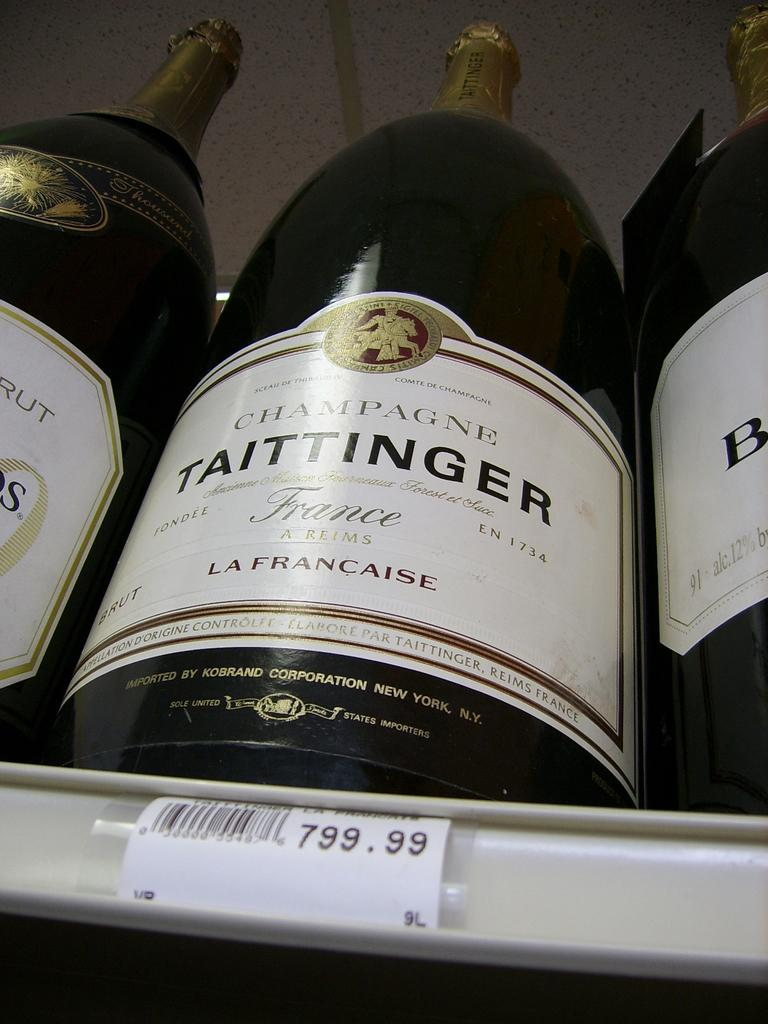<image>
Write a terse but informative summary of the picture. Three bottles of Taittinger champagne are on a shelf waiting to be sold. 